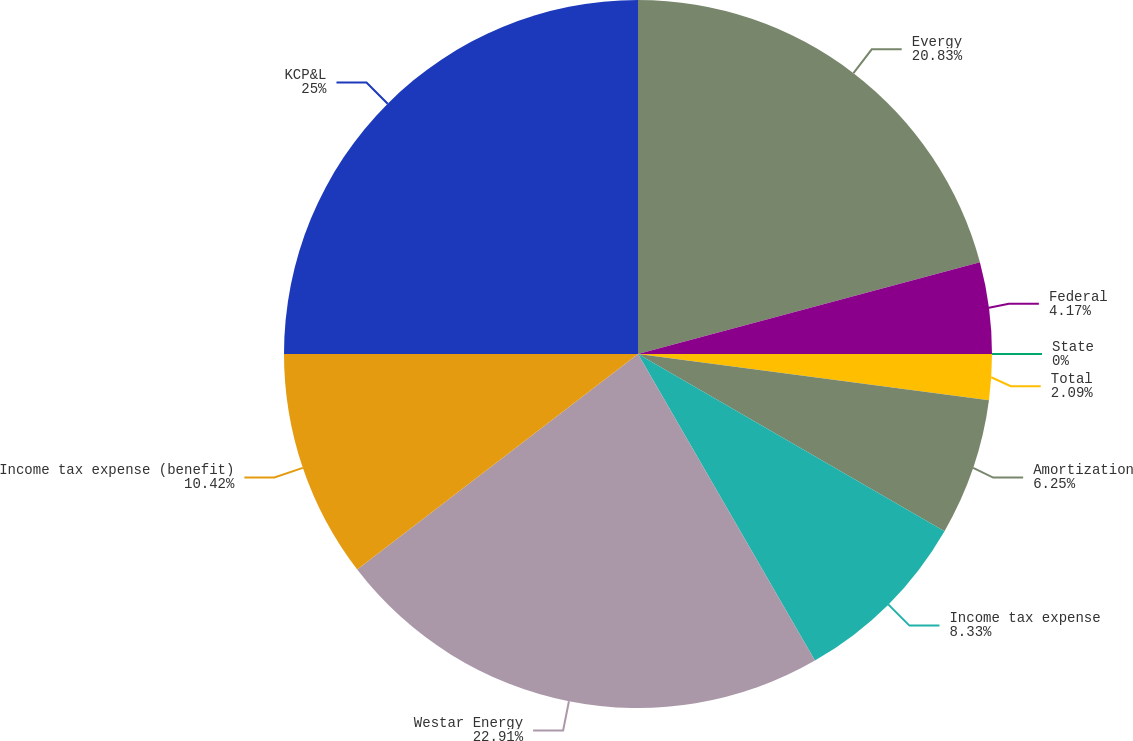<chart> <loc_0><loc_0><loc_500><loc_500><pie_chart><fcel>Evergy<fcel>Federal<fcel>State<fcel>Total<fcel>Amortization<fcel>Income tax expense<fcel>Westar Energy<fcel>Income tax expense (benefit)<fcel>KCP&L<nl><fcel>20.83%<fcel>4.17%<fcel>0.0%<fcel>2.09%<fcel>6.25%<fcel>8.33%<fcel>22.91%<fcel>10.42%<fcel>25.0%<nl></chart> 